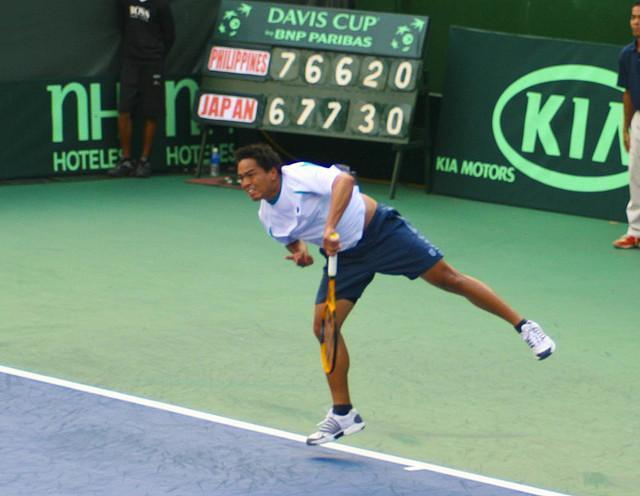How many people are there?
Give a very brief answer. 3. 